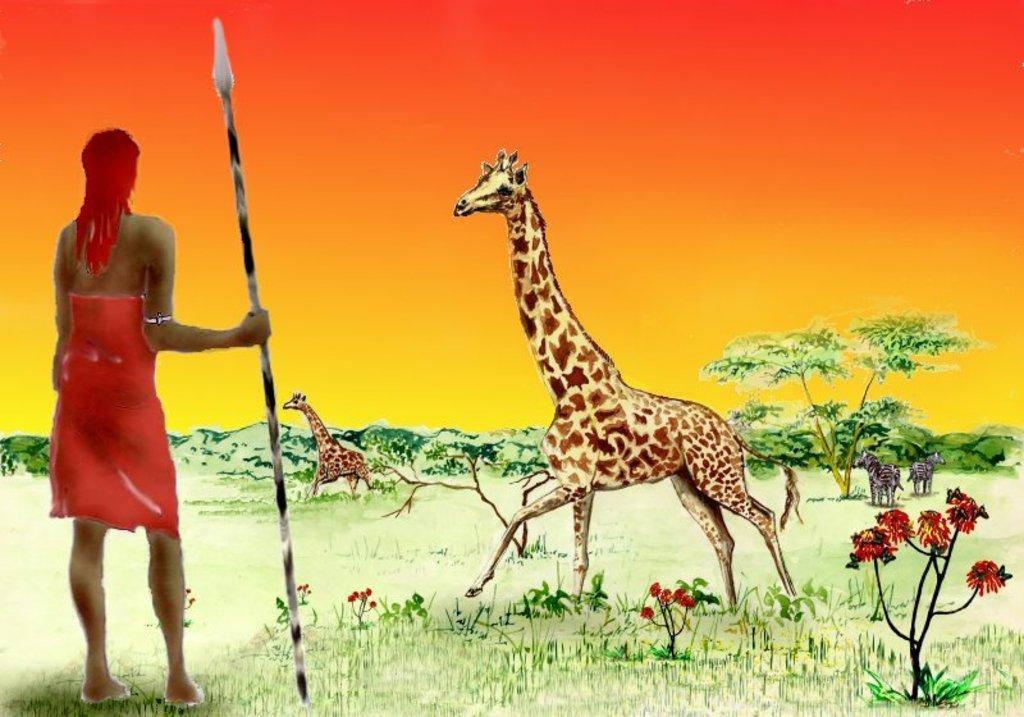How would you summarize this image in a sentence or two? In this image we can see an animated person and a person holding an object. There are many trees and plants in the image. We can see the sky in the image. There are many hills in the image. We can see many flowers to the plants. There is a grassy land in the image. There are few animals in the image. 